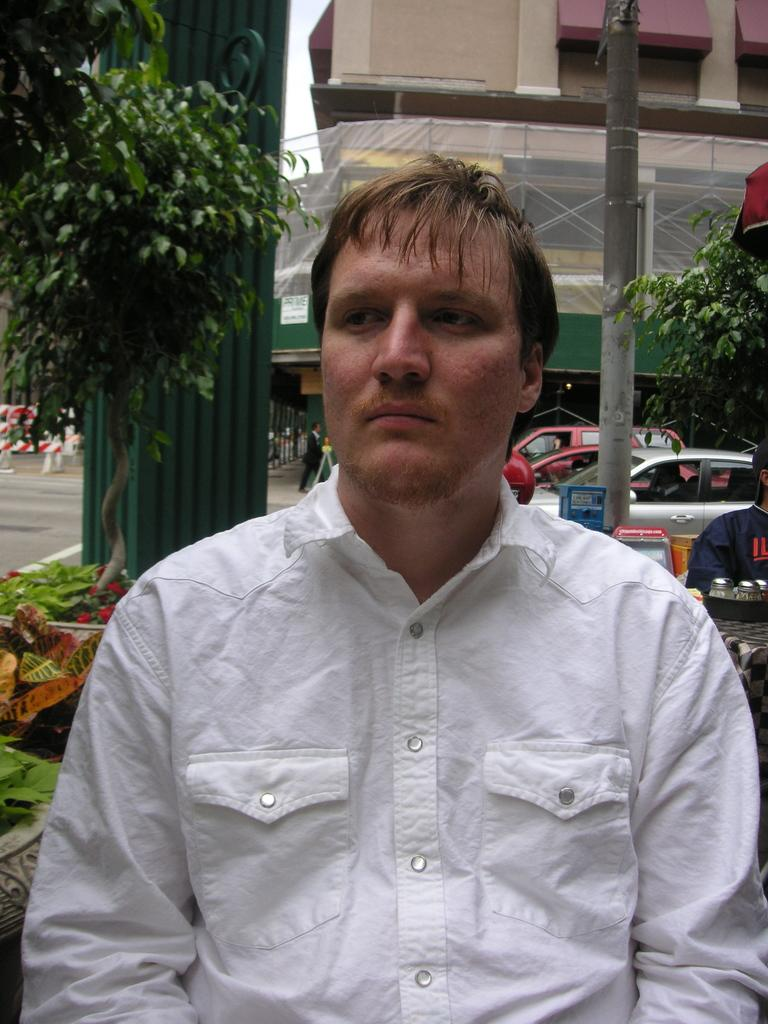What is the man in the image wearing? The man is wearing a white shirt in the image. Where is the man positioned in the image? The man is standing in the front of the image. What can be seen on the road in the image? There are vehicles on the road in the image. What type of vegetation is present on either side of the road? Trees are present on either side of the road in the image. What structure can be seen in the background of the image? There is a building visible in the background of the image. What type of music is the man playing on his tail in the image? There is no mention of a tail or music in the image; the man is simply standing in a front position. 